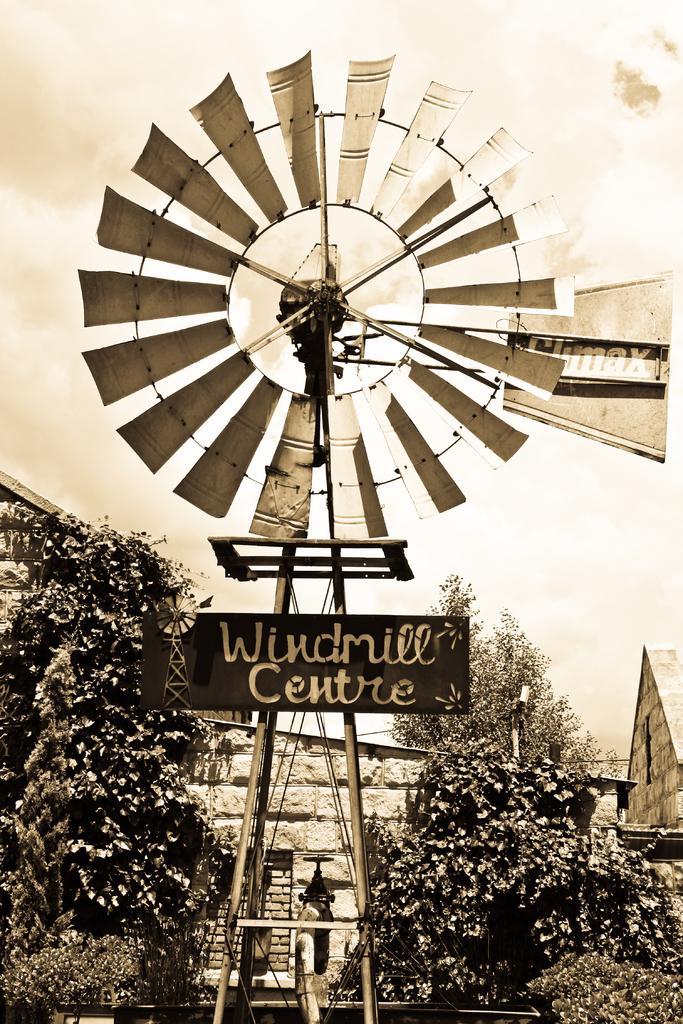Can you describe this image briefly? In this image we can see a windmill on which it is written as windmill center and in the background of the image there are some trees, houses and clear sky. 